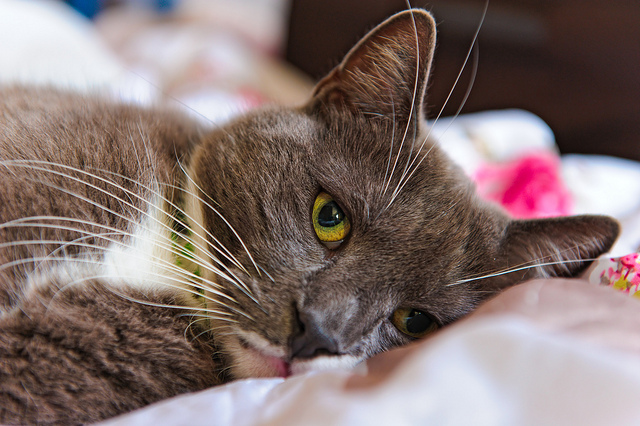What could make the cat purr happily? The cat could purr happily if it receives some gentle petting from its owner, enjoys a tasty treat, or cuddles up in a warm, cozy spot. The presence of a favorite toy or a friendly companion could also bring a sense of joy and contentment to the cat, making it purr with delight. Suppose there’s a hidden story behind this cat’s life. What could it be? Once upon a time, this seemingly ordinary cat was actually a guardian of ancient secrets. In its younger days, it lived in a grand library filled with mystical texts and artifacts. The cat was entrusted with a powerful amulet that held the key to unlocking worlds beyond imagination. Its days were spent exploring ancient scrolls and deciphering cryptic symbols. But a dark force threatened the sanctity of the library, and the brave cat, with a group of loyal allies, set off on a quest to safeguard the amulet and restore balance. Now in its quiet moments on the cozy bed, the cat often reflects on those adventurous times, guarding its mysterious past with an air of wisdom and melancholy. 